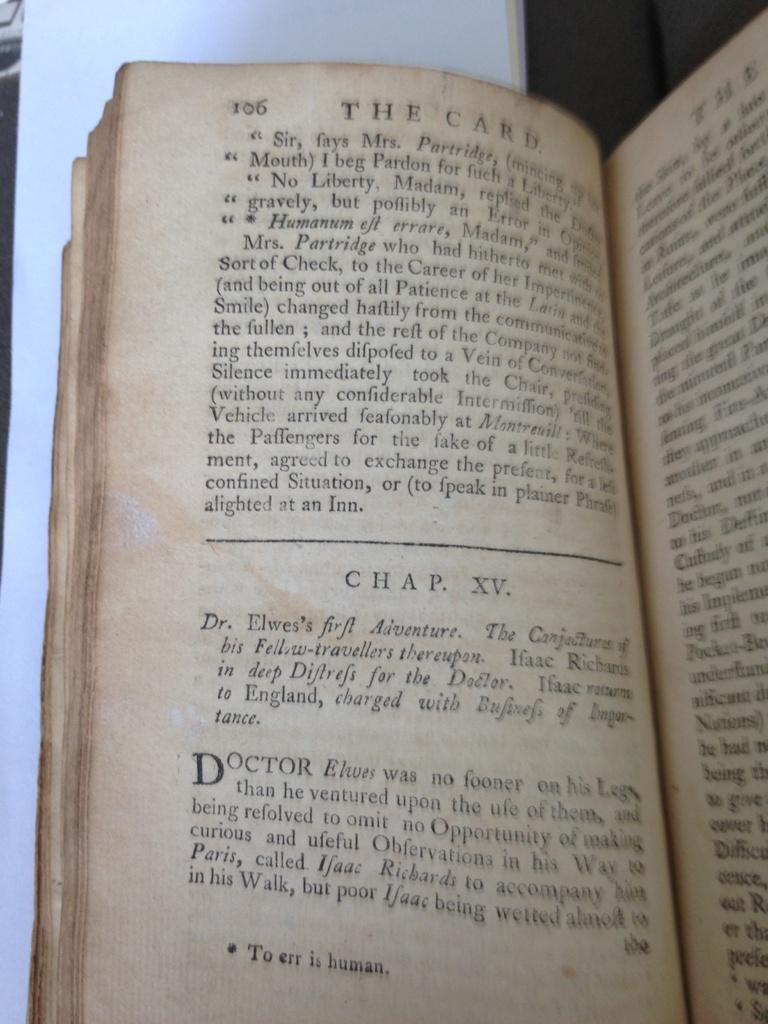Could you give a brief overview of what you see in this image? There is a book with pages. On that something is written. 